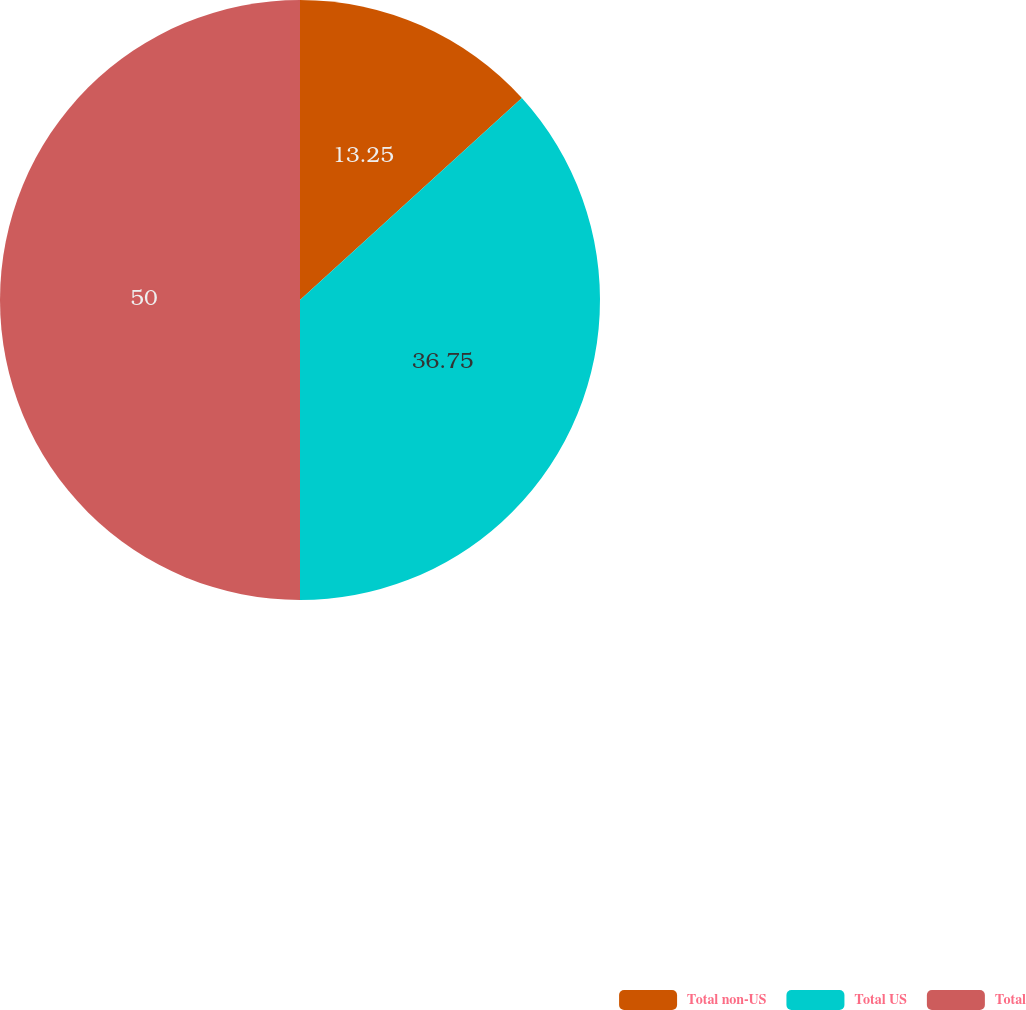Convert chart. <chart><loc_0><loc_0><loc_500><loc_500><pie_chart><fcel>Total non-US<fcel>Total US<fcel>Total<nl><fcel>13.25%<fcel>36.75%<fcel>50.0%<nl></chart> 